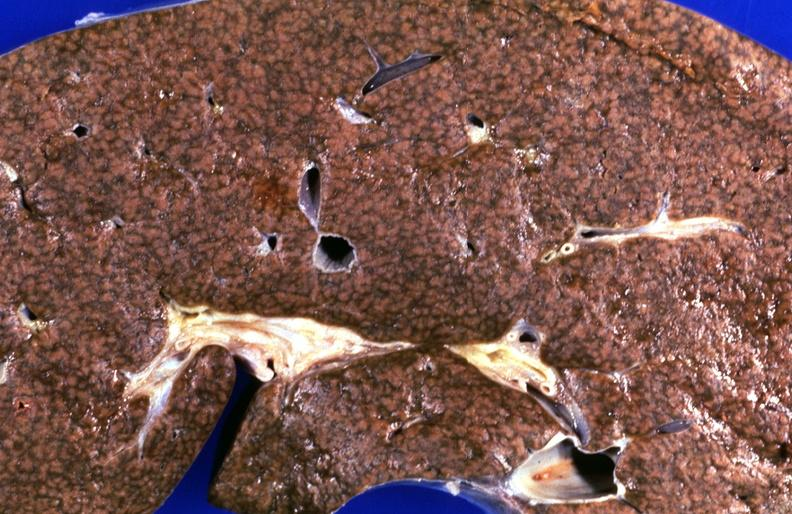s hepatobiliary present?
Answer the question using a single word or phrase. Yes 